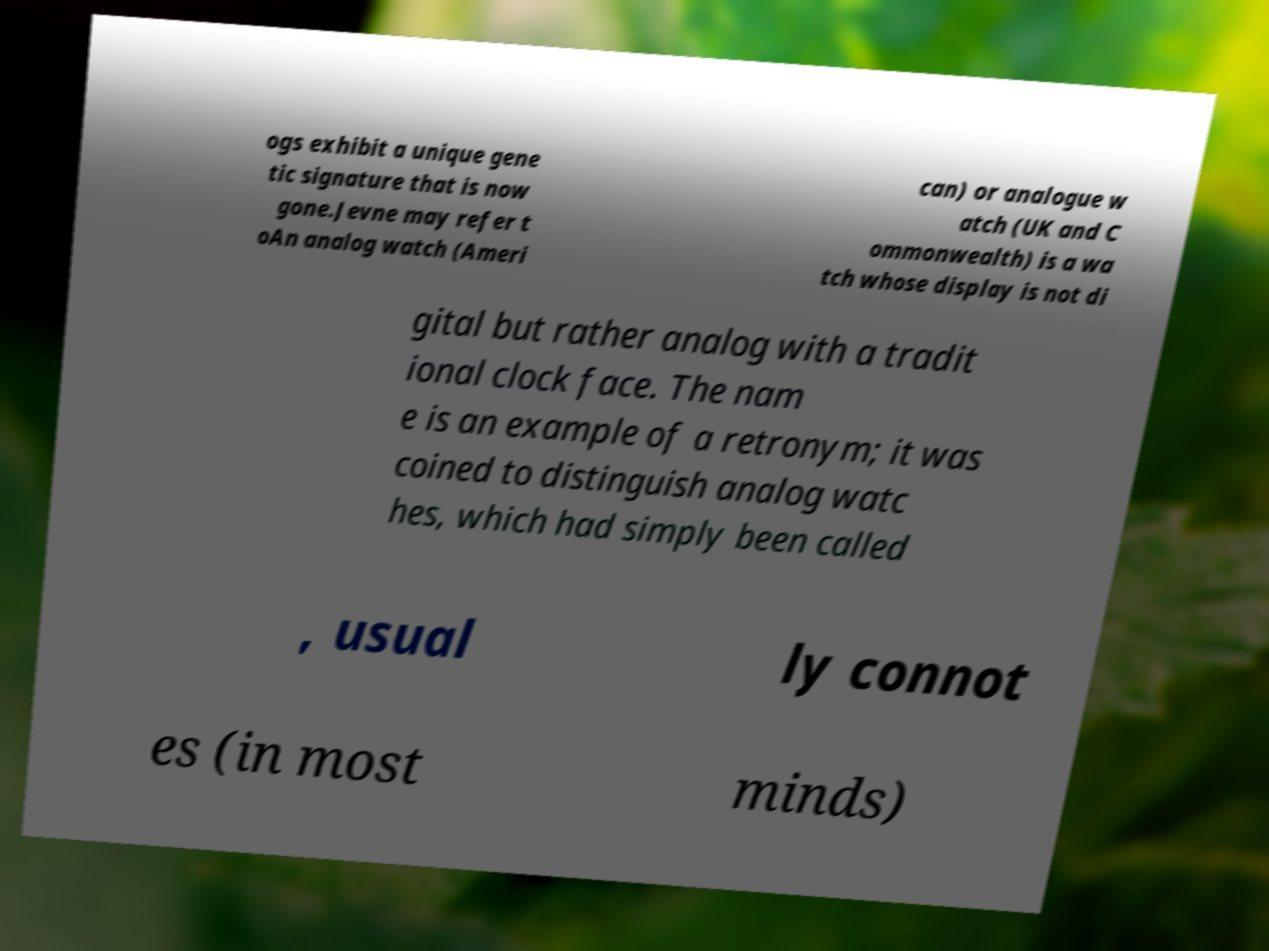Please identify and transcribe the text found in this image. ogs exhibit a unique gene tic signature that is now gone.Jevne may refer t oAn analog watch (Ameri can) or analogue w atch (UK and C ommonwealth) is a wa tch whose display is not di gital but rather analog with a tradit ional clock face. The nam e is an example of a retronym; it was coined to distinguish analog watc hes, which had simply been called , usual ly connot es (in most minds) 